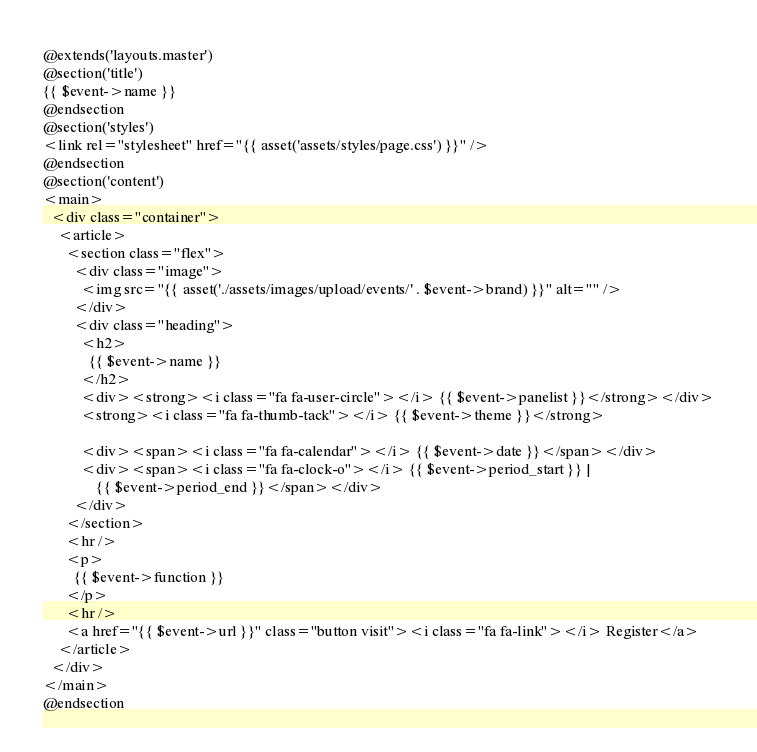Convert code to text. <code><loc_0><loc_0><loc_500><loc_500><_PHP_>@extends('layouts.master')
@section('title')
{{ $event->name }}
@endsection
@section('styles')
<link rel="stylesheet" href="{{ asset('assets/styles/page.css') }}" />
@endsection
@section('content')
<main>
  <div class="container">
    <article>
      <section class="flex">
        <div class="image">
          <img src="{{ asset('./assets/images/upload/events/' . $event->brand) }}" alt="" />
        </div>
        <div class="heading">
          <h2>
            {{ $event->name }}
          </h2>
          <div><strong><i class="fa fa-user-circle"></i> {{ $event->panelist }}</strong></div>
          <strong><i class="fa fa-thumb-tack"></i> {{ $event->theme }}</strong>

          <div><span><i class="fa fa-calendar"></i> {{ $event->date }}</span></div>
          <div><span><i class="fa fa-clock-o"></i> {{ $event->period_start }} |
              {{ $event->period_end }}</span></div>
        </div>
      </section>
      <hr />
      <p>
        {{ $event->function }}
      </p>
      <hr />
      <a href="{{ $event->url }}" class="button visit"><i class="fa fa-link"></i> Register</a>
    </article>
  </div>
</main>
@endsection
</code> 